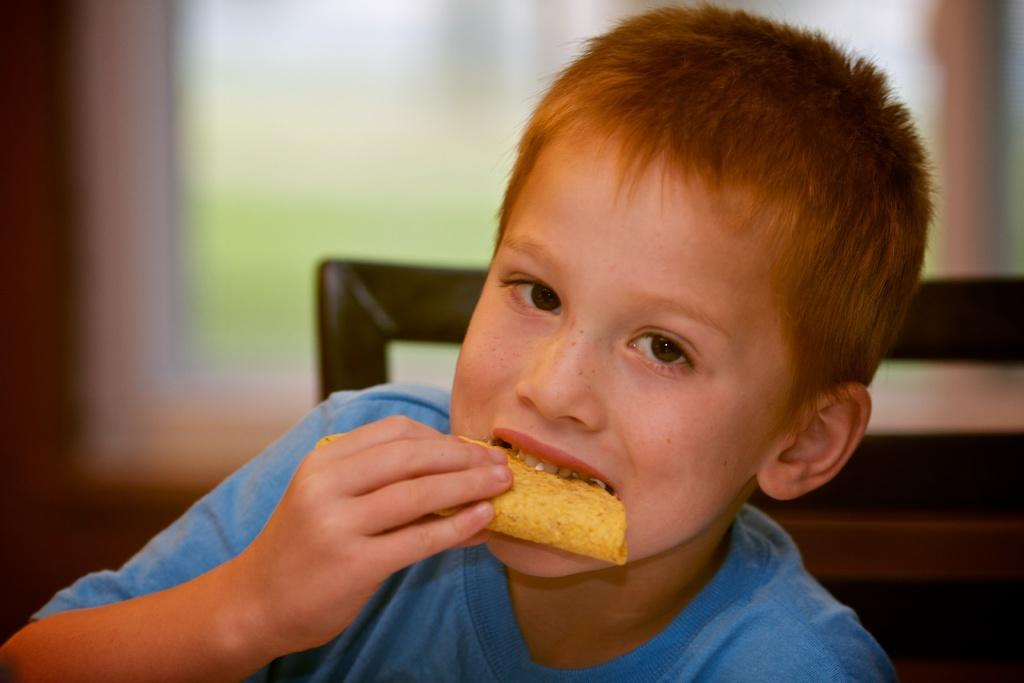Where was the image taken? The image is taken indoors. What can be seen in the background of the image? There is a window in the background of the image. What is the boy doing in the image? The boy is sitting on a chair in the middle of the image. What is the boy holding or eating in the image? The boy is having a biscuit. What type of club does the boy belong to in the image? There is no indication in the image that the boy belongs to any club. 